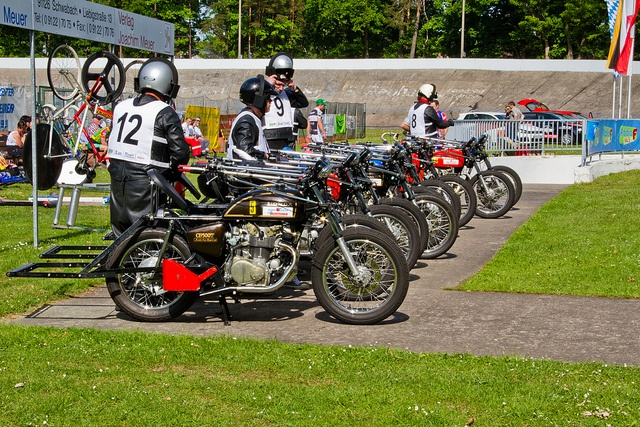Describe the objects in this image and their specific colors. I can see motorcycle in gray, black, darkgray, and darkgreen tones, people in gray, black, white, and darkgray tones, motorcycle in gray, black, and darkgray tones, people in gray, black, lavender, and darkgray tones, and people in gray, black, lightgray, and darkgray tones in this image. 